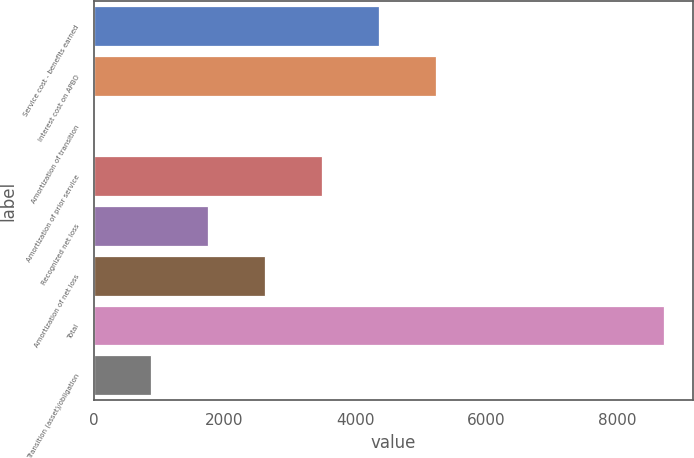Convert chart to OTSL. <chart><loc_0><loc_0><loc_500><loc_500><bar_chart><fcel>Service cost - benefits earned<fcel>Interest cost on APBO<fcel>Amortization of transition<fcel>Amortization of prior service<fcel>Recognized net loss<fcel>Amortization of net loss<fcel>Total<fcel>Transition (asset)/obligation<nl><fcel>4359.5<fcel>5229.8<fcel>8<fcel>3489.2<fcel>1748.6<fcel>2618.9<fcel>8711<fcel>878.3<nl></chart> 